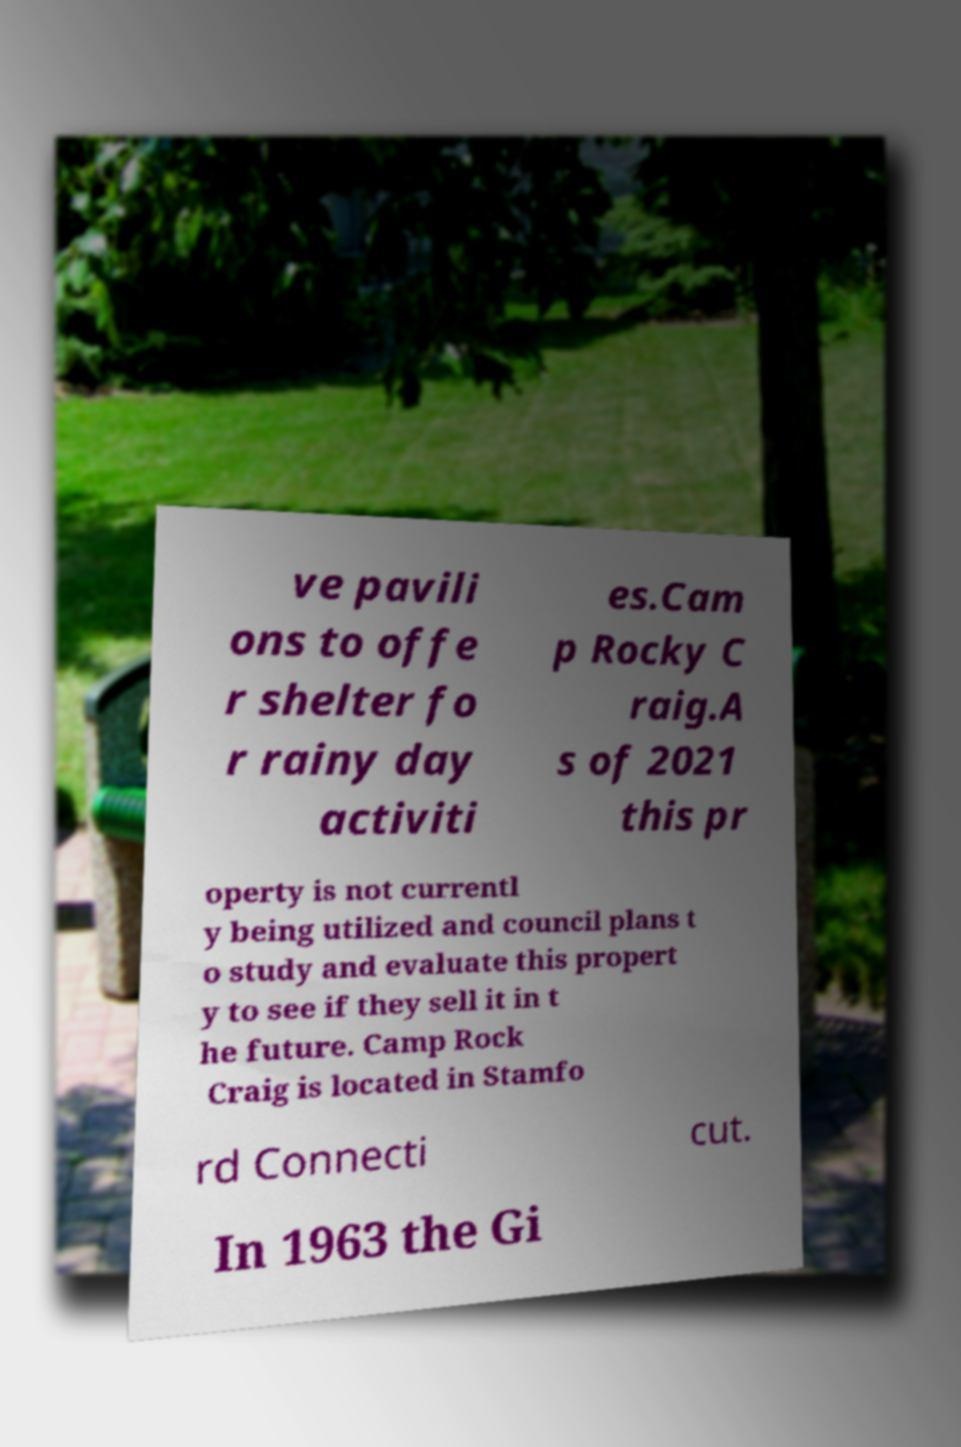I need the written content from this picture converted into text. Can you do that? ve pavili ons to offe r shelter fo r rainy day activiti es.Cam p Rocky C raig.A s of 2021 this pr operty is not currentl y being utilized and council plans t o study and evaluate this propert y to see if they sell it in t he future. Camp Rock Craig is located in Stamfo rd Connecti cut. In 1963 the Gi 